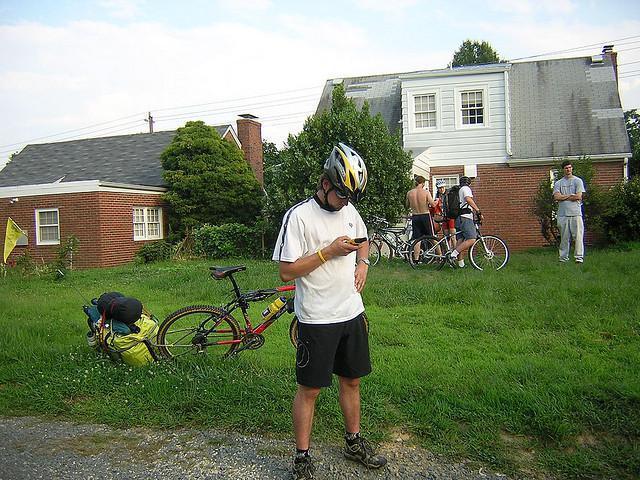How many people are there?
Give a very brief answer. 2. How many bicycles are there?
Give a very brief answer. 2. How many bottles are on the table?
Give a very brief answer. 0. 